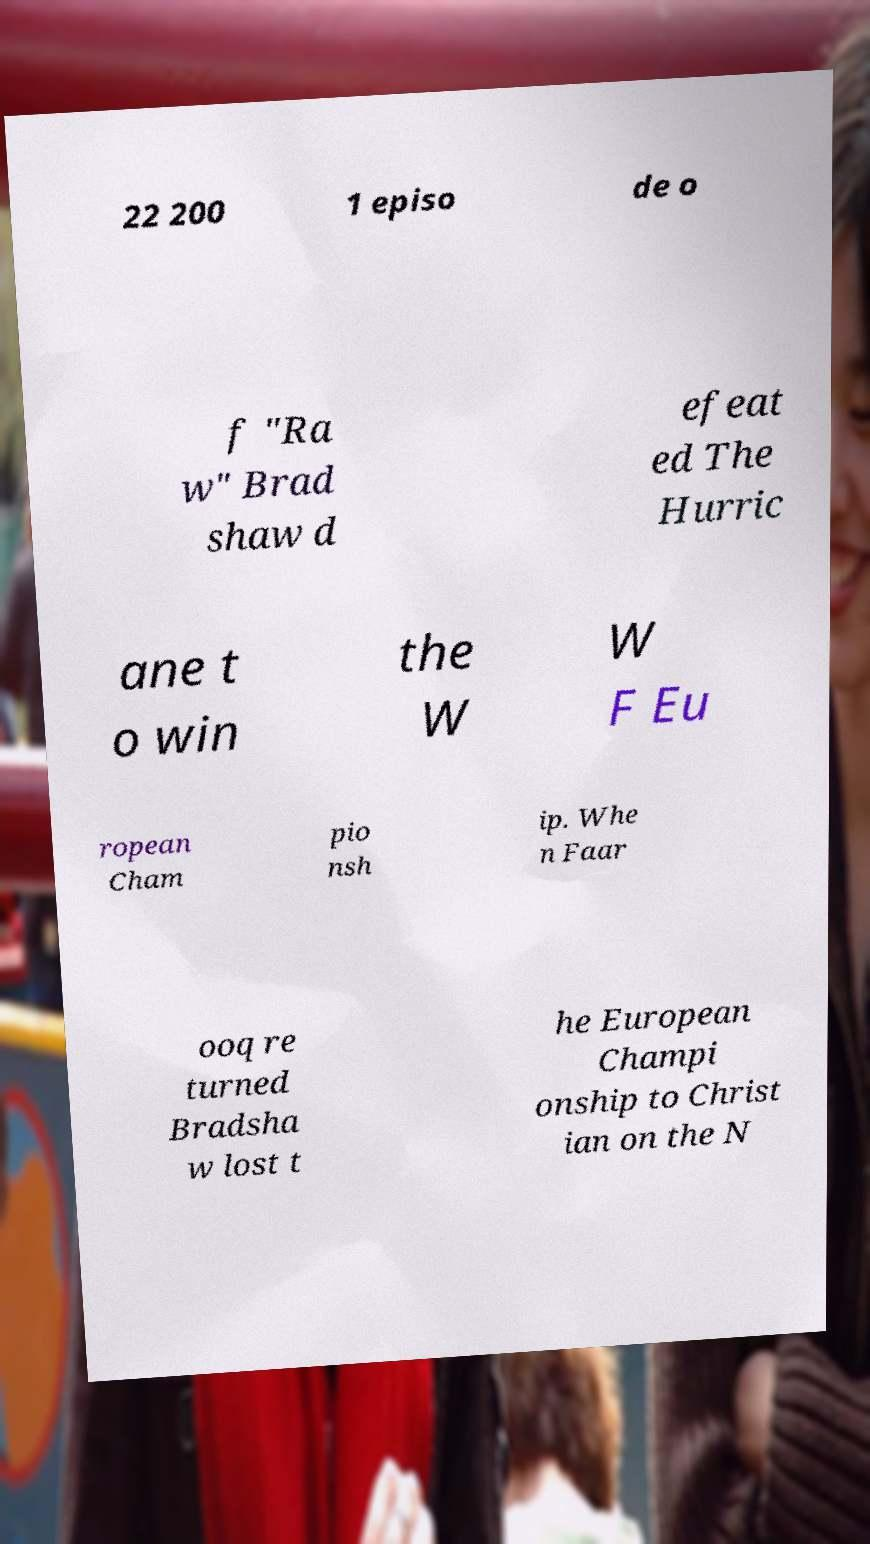For documentation purposes, I need the text within this image transcribed. Could you provide that? 22 200 1 episo de o f "Ra w" Brad shaw d efeat ed The Hurric ane t o win the W W F Eu ropean Cham pio nsh ip. Whe n Faar ooq re turned Bradsha w lost t he European Champi onship to Christ ian on the N 